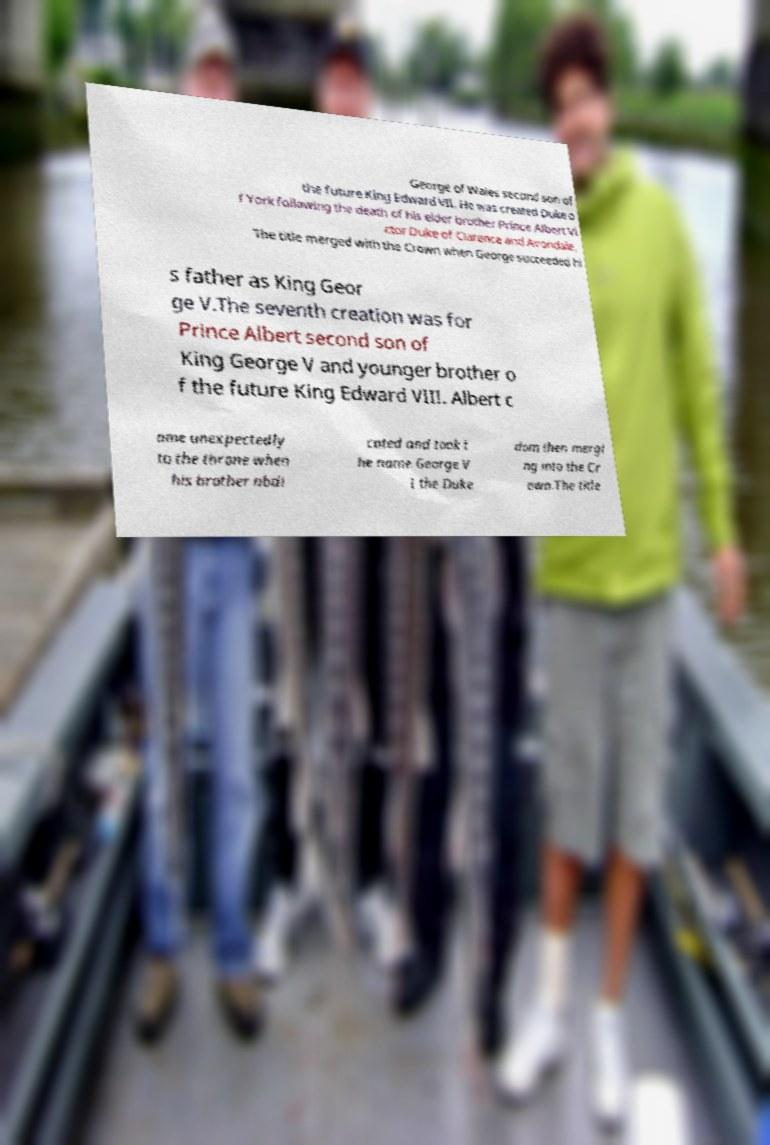There's text embedded in this image that I need extracted. Can you transcribe it verbatim? George of Wales second son of the future King Edward VII. He was created Duke o f York following the death of his elder brother Prince Albert Vi ctor Duke of Clarence and Avondale. The title merged with the Crown when George succeeded hi s father as King Geor ge V.The seventh creation was for Prince Albert second son of King George V and younger brother o f the future King Edward VIII. Albert c ame unexpectedly to the throne when his brother abdi cated and took t he name George V I the Duke dom then mergi ng into the Cr own.The title 